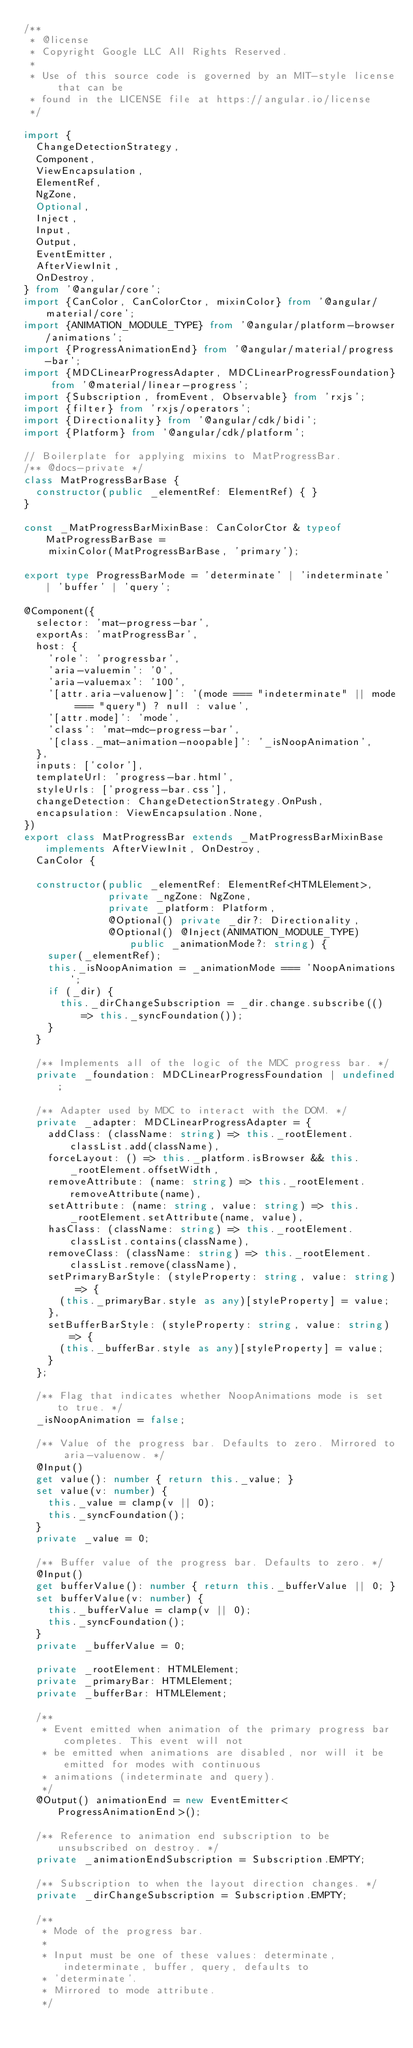Convert code to text. <code><loc_0><loc_0><loc_500><loc_500><_TypeScript_>/**
 * @license
 * Copyright Google LLC All Rights Reserved.
 *
 * Use of this source code is governed by an MIT-style license that can be
 * found in the LICENSE file at https://angular.io/license
 */

import {
  ChangeDetectionStrategy,
  Component,
  ViewEncapsulation,
  ElementRef,
  NgZone,
  Optional,
  Inject,
  Input,
  Output,
  EventEmitter,
  AfterViewInit,
  OnDestroy,
} from '@angular/core';
import {CanColor, CanColorCtor, mixinColor} from '@angular/material/core';
import {ANIMATION_MODULE_TYPE} from '@angular/platform-browser/animations';
import {ProgressAnimationEnd} from '@angular/material/progress-bar';
import {MDCLinearProgressAdapter, MDCLinearProgressFoundation} from '@material/linear-progress';
import {Subscription, fromEvent, Observable} from 'rxjs';
import {filter} from 'rxjs/operators';
import {Directionality} from '@angular/cdk/bidi';
import {Platform} from '@angular/cdk/platform';

// Boilerplate for applying mixins to MatProgressBar.
/** @docs-private */
class MatProgressBarBase {
  constructor(public _elementRef: ElementRef) { }
}

const _MatProgressBarMixinBase: CanColorCtor & typeof MatProgressBarBase =
    mixinColor(MatProgressBarBase, 'primary');

export type ProgressBarMode = 'determinate' | 'indeterminate' | 'buffer' | 'query';

@Component({
  selector: 'mat-progress-bar',
  exportAs: 'matProgressBar',
  host: {
    'role': 'progressbar',
    'aria-valuemin': '0',
    'aria-valuemax': '100',
    '[attr.aria-valuenow]': '(mode === "indeterminate" || mode === "query") ? null : value',
    '[attr.mode]': 'mode',
    'class': 'mat-mdc-progress-bar',
    '[class._mat-animation-noopable]': '_isNoopAnimation',
  },
  inputs: ['color'],
  templateUrl: 'progress-bar.html',
  styleUrls: ['progress-bar.css'],
  changeDetection: ChangeDetectionStrategy.OnPush,
  encapsulation: ViewEncapsulation.None,
})
export class MatProgressBar extends _MatProgressBarMixinBase implements AfterViewInit, OnDestroy,
  CanColor {

  constructor(public _elementRef: ElementRef<HTMLElement>,
              private _ngZone: NgZone,
              private _platform: Platform,
              @Optional() private _dir?: Directionality,
              @Optional() @Inject(ANIMATION_MODULE_TYPE) public _animationMode?: string) {
    super(_elementRef);
    this._isNoopAnimation = _animationMode === 'NoopAnimations';
    if (_dir) {
      this._dirChangeSubscription = _dir.change.subscribe(() => this._syncFoundation());
    }
  }

  /** Implements all of the logic of the MDC progress bar. */
  private _foundation: MDCLinearProgressFoundation | undefined;

  /** Adapter used by MDC to interact with the DOM. */
  private _adapter: MDCLinearProgressAdapter = {
    addClass: (className: string) => this._rootElement.classList.add(className),
    forceLayout: () => this._platform.isBrowser && this._rootElement.offsetWidth,
    removeAttribute: (name: string) => this._rootElement.removeAttribute(name),
    setAttribute: (name: string, value: string) => this._rootElement.setAttribute(name, value),
    hasClass: (className: string) => this._rootElement.classList.contains(className),
    removeClass: (className: string) => this._rootElement.classList.remove(className),
    setPrimaryBarStyle: (styleProperty: string, value: string) => {
      (this._primaryBar.style as any)[styleProperty] = value;
    },
    setBufferBarStyle: (styleProperty: string, value: string) => {
      (this._bufferBar.style as any)[styleProperty] = value;
    }
  };

  /** Flag that indicates whether NoopAnimations mode is set to true. */
  _isNoopAnimation = false;

  /** Value of the progress bar. Defaults to zero. Mirrored to aria-valuenow. */
  @Input()
  get value(): number { return this._value; }
  set value(v: number) {
    this._value = clamp(v || 0);
    this._syncFoundation();
  }
  private _value = 0;

  /** Buffer value of the progress bar. Defaults to zero. */
  @Input()
  get bufferValue(): number { return this._bufferValue || 0; }
  set bufferValue(v: number) {
    this._bufferValue = clamp(v || 0);
    this._syncFoundation();
  }
  private _bufferValue = 0;

  private _rootElement: HTMLElement;
  private _primaryBar: HTMLElement;
  private _bufferBar: HTMLElement;

  /**
   * Event emitted when animation of the primary progress bar completes. This event will not
   * be emitted when animations are disabled, nor will it be emitted for modes with continuous
   * animations (indeterminate and query).
   */
  @Output() animationEnd = new EventEmitter<ProgressAnimationEnd>();

  /** Reference to animation end subscription to be unsubscribed on destroy. */
  private _animationEndSubscription = Subscription.EMPTY;

  /** Subscription to when the layout direction changes. */
  private _dirChangeSubscription = Subscription.EMPTY;

  /**
   * Mode of the progress bar.
   *
   * Input must be one of these values: determinate, indeterminate, buffer, query, defaults to
   * 'determinate'.
   * Mirrored to mode attribute.
   */</code> 